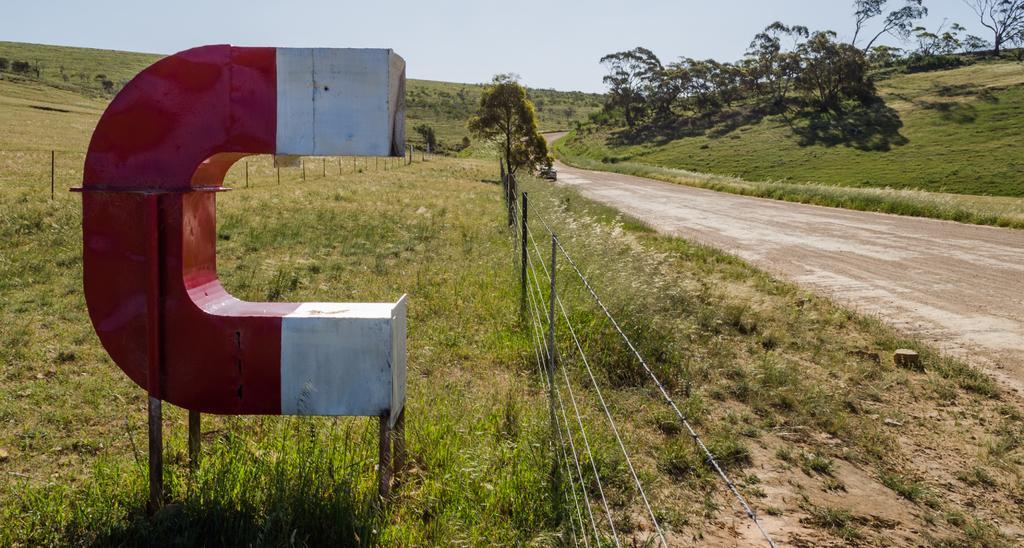Describe this image in one or two sentences. In this image I can see the road, the ground, few trees, the fencing, few poles and a red and white colored object. In the background I can see the sky. 